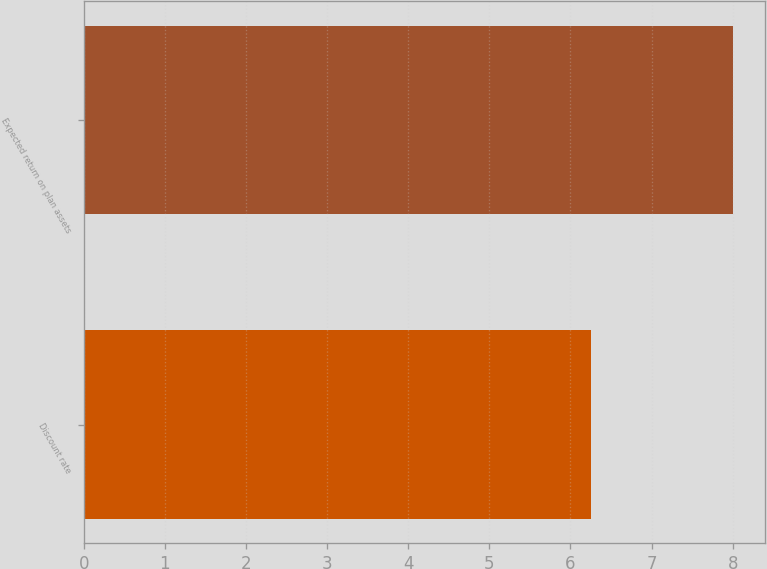<chart> <loc_0><loc_0><loc_500><loc_500><bar_chart><fcel>Discount rate<fcel>Expected return on plan assets<nl><fcel>6.25<fcel>8<nl></chart> 